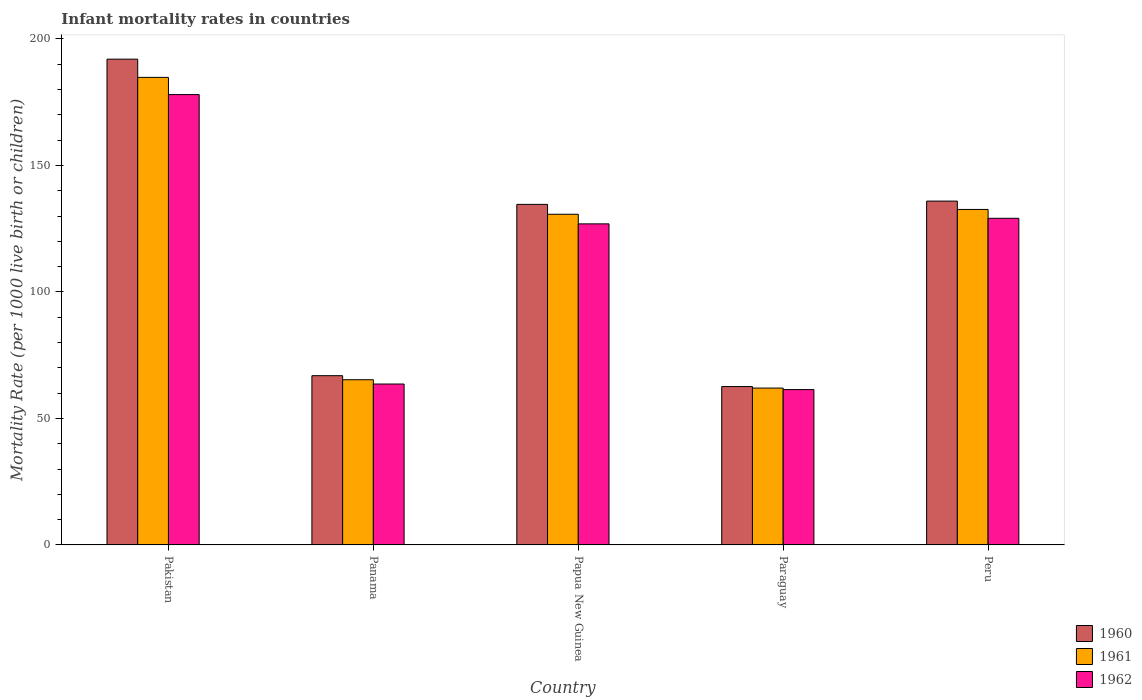How many different coloured bars are there?
Your response must be concise. 3. How many groups of bars are there?
Make the answer very short. 5. Are the number of bars per tick equal to the number of legend labels?
Your answer should be very brief. Yes. How many bars are there on the 4th tick from the left?
Ensure brevity in your answer.  3. How many bars are there on the 1st tick from the right?
Your answer should be very brief. 3. What is the label of the 2nd group of bars from the left?
Ensure brevity in your answer.  Panama. What is the infant mortality rate in 1960 in Panama?
Make the answer very short. 66.9. Across all countries, what is the maximum infant mortality rate in 1962?
Make the answer very short. 178. Across all countries, what is the minimum infant mortality rate in 1961?
Provide a short and direct response. 62. In which country was the infant mortality rate in 1960 maximum?
Give a very brief answer. Pakistan. In which country was the infant mortality rate in 1960 minimum?
Ensure brevity in your answer.  Paraguay. What is the total infant mortality rate in 1962 in the graph?
Your answer should be compact. 559. What is the difference between the infant mortality rate in 1961 in Panama and that in Peru?
Offer a terse response. -67.3. What is the difference between the infant mortality rate in 1960 in Peru and the infant mortality rate in 1962 in Panama?
Give a very brief answer. 72.3. What is the average infant mortality rate in 1962 per country?
Provide a short and direct response. 111.8. What is the difference between the infant mortality rate of/in 1961 and infant mortality rate of/in 1962 in Papua New Guinea?
Make the answer very short. 3.8. What is the ratio of the infant mortality rate in 1961 in Paraguay to that in Peru?
Offer a very short reply. 0.47. Is the infant mortality rate in 1961 in Pakistan less than that in Paraguay?
Your response must be concise. No. What is the difference between the highest and the second highest infant mortality rate in 1960?
Give a very brief answer. 57.4. What is the difference between the highest and the lowest infant mortality rate in 1961?
Offer a very short reply. 122.8. In how many countries, is the infant mortality rate in 1962 greater than the average infant mortality rate in 1962 taken over all countries?
Make the answer very short. 3. What does the 3rd bar from the right in Panama represents?
Make the answer very short. 1960. How many bars are there?
Your response must be concise. 15. Are all the bars in the graph horizontal?
Offer a terse response. No. What is the difference between two consecutive major ticks on the Y-axis?
Keep it short and to the point. 50. Are the values on the major ticks of Y-axis written in scientific E-notation?
Ensure brevity in your answer.  No. What is the title of the graph?
Ensure brevity in your answer.  Infant mortality rates in countries. What is the label or title of the Y-axis?
Provide a succinct answer. Mortality Rate (per 1000 live birth or children). What is the Mortality Rate (per 1000 live birth or children) of 1960 in Pakistan?
Your answer should be very brief. 192. What is the Mortality Rate (per 1000 live birth or children) of 1961 in Pakistan?
Provide a succinct answer. 184.8. What is the Mortality Rate (per 1000 live birth or children) in 1962 in Pakistan?
Ensure brevity in your answer.  178. What is the Mortality Rate (per 1000 live birth or children) of 1960 in Panama?
Ensure brevity in your answer.  66.9. What is the Mortality Rate (per 1000 live birth or children) of 1961 in Panama?
Give a very brief answer. 65.3. What is the Mortality Rate (per 1000 live birth or children) in 1962 in Panama?
Offer a very short reply. 63.6. What is the Mortality Rate (per 1000 live birth or children) in 1960 in Papua New Guinea?
Provide a short and direct response. 134.6. What is the Mortality Rate (per 1000 live birth or children) in 1961 in Papua New Guinea?
Give a very brief answer. 130.7. What is the Mortality Rate (per 1000 live birth or children) of 1962 in Papua New Guinea?
Provide a short and direct response. 126.9. What is the Mortality Rate (per 1000 live birth or children) of 1960 in Paraguay?
Ensure brevity in your answer.  62.6. What is the Mortality Rate (per 1000 live birth or children) of 1961 in Paraguay?
Provide a succinct answer. 62. What is the Mortality Rate (per 1000 live birth or children) of 1962 in Paraguay?
Keep it short and to the point. 61.4. What is the Mortality Rate (per 1000 live birth or children) in 1960 in Peru?
Keep it short and to the point. 135.9. What is the Mortality Rate (per 1000 live birth or children) of 1961 in Peru?
Your answer should be compact. 132.6. What is the Mortality Rate (per 1000 live birth or children) of 1962 in Peru?
Your answer should be very brief. 129.1. Across all countries, what is the maximum Mortality Rate (per 1000 live birth or children) of 1960?
Your response must be concise. 192. Across all countries, what is the maximum Mortality Rate (per 1000 live birth or children) of 1961?
Offer a terse response. 184.8. Across all countries, what is the maximum Mortality Rate (per 1000 live birth or children) in 1962?
Provide a short and direct response. 178. Across all countries, what is the minimum Mortality Rate (per 1000 live birth or children) of 1960?
Your response must be concise. 62.6. Across all countries, what is the minimum Mortality Rate (per 1000 live birth or children) in 1962?
Give a very brief answer. 61.4. What is the total Mortality Rate (per 1000 live birth or children) of 1960 in the graph?
Ensure brevity in your answer.  592. What is the total Mortality Rate (per 1000 live birth or children) of 1961 in the graph?
Provide a succinct answer. 575.4. What is the total Mortality Rate (per 1000 live birth or children) in 1962 in the graph?
Your answer should be very brief. 559. What is the difference between the Mortality Rate (per 1000 live birth or children) in 1960 in Pakistan and that in Panama?
Provide a short and direct response. 125.1. What is the difference between the Mortality Rate (per 1000 live birth or children) of 1961 in Pakistan and that in Panama?
Your answer should be very brief. 119.5. What is the difference between the Mortality Rate (per 1000 live birth or children) in 1962 in Pakistan and that in Panama?
Your answer should be very brief. 114.4. What is the difference between the Mortality Rate (per 1000 live birth or children) of 1960 in Pakistan and that in Papua New Guinea?
Your answer should be compact. 57.4. What is the difference between the Mortality Rate (per 1000 live birth or children) of 1961 in Pakistan and that in Papua New Guinea?
Make the answer very short. 54.1. What is the difference between the Mortality Rate (per 1000 live birth or children) of 1962 in Pakistan and that in Papua New Guinea?
Give a very brief answer. 51.1. What is the difference between the Mortality Rate (per 1000 live birth or children) of 1960 in Pakistan and that in Paraguay?
Your answer should be compact. 129.4. What is the difference between the Mortality Rate (per 1000 live birth or children) of 1961 in Pakistan and that in Paraguay?
Keep it short and to the point. 122.8. What is the difference between the Mortality Rate (per 1000 live birth or children) in 1962 in Pakistan and that in Paraguay?
Provide a short and direct response. 116.6. What is the difference between the Mortality Rate (per 1000 live birth or children) of 1960 in Pakistan and that in Peru?
Keep it short and to the point. 56.1. What is the difference between the Mortality Rate (per 1000 live birth or children) of 1961 in Pakistan and that in Peru?
Provide a short and direct response. 52.2. What is the difference between the Mortality Rate (per 1000 live birth or children) in 1962 in Pakistan and that in Peru?
Make the answer very short. 48.9. What is the difference between the Mortality Rate (per 1000 live birth or children) of 1960 in Panama and that in Papua New Guinea?
Ensure brevity in your answer.  -67.7. What is the difference between the Mortality Rate (per 1000 live birth or children) of 1961 in Panama and that in Papua New Guinea?
Give a very brief answer. -65.4. What is the difference between the Mortality Rate (per 1000 live birth or children) in 1962 in Panama and that in Papua New Guinea?
Provide a succinct answer. -63.3. What is the difference between the Mortality Rate (per 1000 live birth or children) of 1960 in Panama and that in Paraguay?
Ensure brevity in your answer.  4.3. What is the difference between the Mortality Rate (per 1000 live birth or children) in 1962 in Panama and that in Paraguay?
Give a very brief answer. 2.2. What is the difference between the Mortality Rate (per 1000 live birth or children) of 1960 in Panama and that in Peru?
Your response must be concise. -69. What is the difference between the Mortality Rate (per 1000 live birth or children) of 1961 in Panama and that in Peru?
Provide a succinct answer. -67.3. What is the difference between the Mortality Rate (per 1000 live birth or children) in 1962 in Panama and that in Peru?
Your response must be concise. -65.5. What is the difference between the Mortality Rate (per 1000 live birth or children) of 1961 in Papua New Guinea and that in Paraguay?
Ensure brevity in your answer.  68.7. What is the difference between the Mortality Rate (per 1000 live birth or children) in 1962 in Papua New Guinea and that in Paraguay?
Provide a succinct answer. 65.5. What is the difference between the Mortality Rate (per 1000 live birth or children) of 1961 in Papua New Guinea and that in Peru?
Your answer should be very brief. -1.9. What is the difference between the Mortality Rate (per 1000 live birth or children) of 1962 in Papua New Guinea and that in Peru?
Your answer should be compact. -2.2. What is the difference between the Mortality Rate (per 1000 live birth or children) of 1960 in Paraguay and that in Peru?
Your answer should be very brief. -73.3. What is the difference between the Mortality Rate (per 1000 live birth or children) of 1961 in Paraguay and that in Peru?
Ensure brevity in your answer.  -70.6. What is the difference between the Mortality Rate (per 1000 live birth or children) of 1962 in Paraguay and that in Peru?
Your answer should be compact. -67.7. What is the difference between the Mortality Rate (per 1000 live birth or children) in 1960 in Pakistan and the Mortality Rate (per 1000 live birth or children) in 1961 in Panama?
Your answer should be very brief. 126.7. What is the difference between the Mortality Rate (per 1000 live birth or children) of 1960 in Pakistan and the Mortality Rate (per 1000 live birth or children) of 1962 in Panama?
Offer a terse response. 128.4. What is the difference between the Mortality Rate (per 1000 live birth or children) of 1961 in Pakistan and the Mortality Rate (per 1000 live birth or children) of 1962 in Panama?
Make the answer very short. 121.2. What is the difference between the Mortality Rate (per 1000 live birth or children) in 1960 in Pakistan and the Mortality Rate (per 1000 live birth or children) in 1961 in Papua New Guinea?
Offer a very short reply. 61.3. What is the difference between the Mortality Rate (per 1000 live birth or children) of 1960 in Pakistan and the Mortality Rate (per 1000 live birth or children) of 1962 in Papua New Guinea?
Make the answer very short. 65.1. What is the difference between the Mortality Rate (per 1000 live birth or children) of 1961 in Pakistan and the Mortality Rate (per 1000 live birth or children) of 1962 in Papua New Guinea?
Provide a succinct answer. 57.9. What is the difference between the Mortality Rate (per 1000 live birth or children) in 1960 in Pakistan and the Mortality Rate (per 1000 live birth or children) in 1961 in Paraguay?
Provide a succinct answer. 130. What is the difference between the Mortality Rate (per 1000 live birth or children) of 1960 in Pakistan and the Mortality Rate (per 1000 live birth or children) of 1962 in Paraguay?
Your answer should be compact. 130.6. What is the difference between the Mortality Rate (per 1000 live birth or children) in 1961 in Pakistan and the Mortality Rate (per 1000 live birth or children) in 1962 in Paraguay?
Offer a very short reply. 123.4. What is the difference between the Mortality Rate (per 1000 live birth or children) of 1960 in Pakistan and the Mortality Rate (per 1000 live birth or children) of 1961 in Peru?
Provide a succinct answer. 59.4. What is the difference between the Mortality Rate (per 1000 live birth or children) in 1960 in Pakistan and the Mortality Rate (per 1000 live birth or children) in 1962 in Peru?
Provide a succinct answer. 62.9. What is the difference between the Mortality Rate (per 1000 live birth or children) in 1961 in Pakistan and the Mortality Rate (per 1000 live birth or children) in 1962 in Peru?
Offer a very short reply. 55.7. What is the difference between the Mortality Rate (per 1000 live birth or children) of 1960 in Panama and the Mortality Rate (per 1000 live birth or children) of 1961 in Papua New Guinea?
Your answer should be compact. -63.8. What is the difference between the Mortality Rate (per 1000 live birth or children) in 1960 in Panama and the Mortality Rate (per 1000 live birth or children) in 1962 in Papua New Guinea?
Offer a terse response. -60. What is the difference between the Mortality Rate (per 1000 live birth or children) in 1961 in Panama and the Mortality Rate (per 1000 live birth or children) in 1962 in Papua New Guinea?
Keep it short and to the point. -61.6. What is the difference between the Mortality Rate (per 1000 live birth or children) in 1960 in Panama and the Mortality Rate (per 1000 live birth or children) in 1961 in Peru?
Provide a succinct answer. -65.7. What is the difference between the Mortality Rate (per 1000 live birth or children) of 1960 in Panama and the Mortality Rate (per 1000 live birth or children) of 1962 in Peru?
Provide a succinct answer. -62.2. What is the difference between the Mortality Rate (per 1000 live birth or children) of 1961 in Panama and the Mortality Rate (per 1000 live birth or children) of 1962 in Peru?
Keep it short and to the point. -63.8. What is the difference between the Mortality Rate (per 1000 live birth or children) of 1960 in Papua New Guinea and the Mortality Rate (per 1000 live birth or children) of 1961 in Paraguay?
Your answer should be compact. 72.6. What is the difference between the Mortality Rate (per 1000 live birth or children) of 1960 in Papua New Guinea and the Mortality Rate (per 1000 live birth or children) of 1962 in Paraguay?
Your response must be concise. 73.2. What is the difference between the Mortality Rate (per 1000 live birth or children) in 1961 in Papua New Guinea and the Mortality Rate (per 1000 live birth or children) in 1962 in Paraguay?
Ensure brevity in your answer.  69.3. What is the difference between the Mortality Rate (per 1000 live birth or children) in 1960 in Papua New Guinea and the Mortality Rate (per 1000 live birth or children) in 1961 in Peru?
Keep it short and to the point. 2. What is the difference between the Mortality Rate (per 1000 live birth or children) in 1960 in Papua New Guinea and the Mortality Rate (per 1000 live birth or children) in 1962 in Peru?
Make the answer very short. 5.5. What is the difference between the Mortality Rate (per 1000 live birth or children) of 1961 in Papua New Guinea and the Mortality Rate (per 1000 live birth or children) of 1962 in Peru?
Make the answer very short. 1.6. What is the difference between the Mortality Rate (per 1000 live birth or children) of 1960 in Paraguay and the Mortality Rate (per 1000 live birth or children) of 1961 in Peru?
Provide a short and direct response. -70. What is the difference between the Mortality Rate (per 1000 live birth or children) of 1960 in Paraguay and the Mortality Rate (per 1000 live birth or children) of 1962 in Peru?
Offer a very short reply. -66.5. What is the difference between the Mortality Rate (per 1000 live birth or children) in 1961 in Paraguay and the Mortality Rate (per 1000 live birth or children) in 1962 in Peru?
Offer a terse response. -67.1. What is the average Mortality Rate (per 1000 live birth or children) in 1960 per country?
Provide a short and direct response. 118.4. What is the average Mortality Rate (per 1000 live birth or children) in 1961 per country?
Offer a very short reply. 115.08. What is the average Mortality Rate (per 1000 live birth or children) of 1962 per country?
Offer a terse response. 111.8. What is the difference between the Mortality Rate (per 1000 live birth or children) of 1960 and Mortality Rate (per 1000 live birth or children) of 1961 in Pakistan?
Provide a succinct answer. 7.2. What is the difference between the Mortality Rate (per 1000 live birth or children) in 1960 and Mortality Rate (per 1000 live birth or children) in 1962 in Pakistan?
Offer a terse response. 14. What is the difference between the Mortality Rate (per 1000 live birth or children) in 1960 and Mortality Rate (per 1000 live birth or children) in 1962 in Papua New Guinea?
Provide a succinct answer. 7.7. What is the difference between the Mortality Rate (per 1000 live birth or children) in 1960 and Mortality Rate (per 1000 live birth or children) in 1962 in Paraguay?
Ensure brevity in your answer.  1.2. What is the difference between the Mortality Rate (per 1000 live birth or children) of 1960 and Mortality Rate (per 1000 live birth or children) of 1961 in Peru?
Keep it short and to the point. 3.3. What is the ratio of the Mortality Rate (per 1000 live birth or children) in 1960 in Pakistan to that in Panama?
Your response must be concise. 2.87. What is the ratio of the Mortality Rate (per 1000 live birth or children) of 1961 in Pakistan to that in Panama?
Offer a very short reply. 2.83. What is the ratio of the Mortality Rate (per 1000 live birth or children) in 1962 in Pakistan to that in Panama?
Your answer should be very brief. 2.8. What is the ratio of the Mortality Rate (per 1000 live birth or children) of 1960 in Pakistan to that in Papua New Guinea?
Offer a terse response. 1.43. What is the ratio of the Mortality Rate (per 1000 live birth or children) in 1961 in Pakistan to that in Papua New Guinea?
Give a very brief answer. 1.41. What is the ratio of the Mortality Rate (per 1000 live birth or children) in 1962 in Pakistan to that in Papua New Guinea?
Your response must be concise. 1.4. What is the ratio of the Mortality Rate (per 1000 live birth or children) of 1960 in Pakistan to that in Paraguay?
Give a very brief answer. 3.07. What is the ratio of the Mortality Rate (per 1000 live birth or children) of 1961 in Pakistan to that in Paraguay?
Give a very brief answer. 2.98. What is the ratio of the Mortality Rate (per 1000 live birth or children) in 1962 in Pakistan to that in Paraguay?
Offer a terse response. 2.9. What is the ratio of the Mortality Rate (per 1000 live birth or children) in 1960 in Pakistan to that in Peru?
Ensure brevity in your answer.  1.41. What is the ratio of the Mortality Rate (per 1000 live birth or children) in 1961 in Pakistan to that in Peru?
Offer a terse response. 1.39. What is the ratio of the Mortality Rate (per 1000 live birth or children) of 1962 in Pakistan to that in Peru?
Your answer should be compact. 1.38. What is the ratio of the Mortality Rate (per 1000 live birth or children) of 1960 in Panama to that in Papua New Guinea?
Give a very brief answer. 0.5. What is the ratio of the Mortality Rate (per 1000 live birth or children) in 1961 in Panama to that in Papua New Guinea?
Keep it short and to the point. 0.5. What is the ratio of the Mortality Rate (per 1000 live birth or children) in 1962 in Panama to that in Papua New Guinea?
Your answer should be very brief. 0.5. What is the ratio of the Mortality Rate (per 1000 live birth or children) of 1960 in Panama to that in Paraguay?
Provide a short and direct response. 1.07. What is the ratio of the Mortality Rate (per 1000 live birth or children) in 1961 in Panama to that in Paraguay?
Ensure brevity in your answer.  1.05. What is the ratio of the Mortality Rate (per 1000 live birth or children) in 1962 in Panama to that in Paraguay?
Your answer should be compact. 1.04. What is the ratio of the Mortality Rate (per 1000 live birth or children) of 1960 in Panama to that in Peru?
Provide a succinct answer. 0.49. What is the ratio of the Mortality Rate (per 1000 live birth or children) in 1961 in Panama to that in Peru?
Your answer should be very brief. 0.49. What is the ratio of the Mortality Rate (per 1000 live birth or children) in 1962 in Panama to that in Peru?
Provide a short and direct response. 0.49. What is the ratio of the Mortality Rate (per 1000 live birth or children) in 1960 in Papua New Guinea to that in Paraguay?
Your response must be concise. 2.15. What is the ratio of the Mortality Rate (per 1000 live birth or children) of 1961 in Papua New Guinea to that in Paraguay?
Offer a terse response. 2.11. What is the ratio of the Mortality Rate (per 1000 live birth or children) in 1962 in Papua New Guinea to that in Paraguay?
Make the answer very short. 2.07. What is the ratio of the Mortality Rate (per 1000 live birth or children) in 1960 in Papua New Guinea to that in Peru?
Offer a terse response. 0.99. What is the ratio of the Mortality Rate (per 1000 live birth or children) of 1961 in Papua New Guinea to that in Peru?
Keep it short and to the point. 0.99. What is the ratio of the Mortality Rate (per 1000 live birth or children) in 1960 in Paraguay to that in Peru?
Your response must be concise. 0.46. What is the ratio of the Mortality Rate (per 1000 live birth or children) in 1961 in Paraguay to that in Peru?
Provide a succinct answer. 0.47. What is the ratio of the Mortality Rate (per 1000 live birth or children) of 1962 in Paraguay to that in Peru?
Keep it short and to the point. 0.48. What is the difference between the highest and the second highest Mortality Rate (per 1000 live birth or children) of 1960?
Make the answer very short. 56.1. What is the difference between the highest and the second highest Mortality Rate (per 1000 live birth or children) of 1961?
Make the answer very short. 52.2. What is the difference between the highest and the second highest Mortality Rate (per 1000 live birth or children) of 1962?
Your answer should be very brief. 48.9. What is the difference between the highest and the lowest Mortality Rate (per 1000 live birth or children) of 1960?
Your response must be concise. 129.4. What is the difference between the highest and the lowest Mortality Rate (per 1000 live birth or children) of 1961?
Provide a short and direct response. 122.8. What is the difference between the highest and the lowest Mortality Rate (per 1000 live birth or children) in 1962?
Keep it short and to the point. 116.6. 